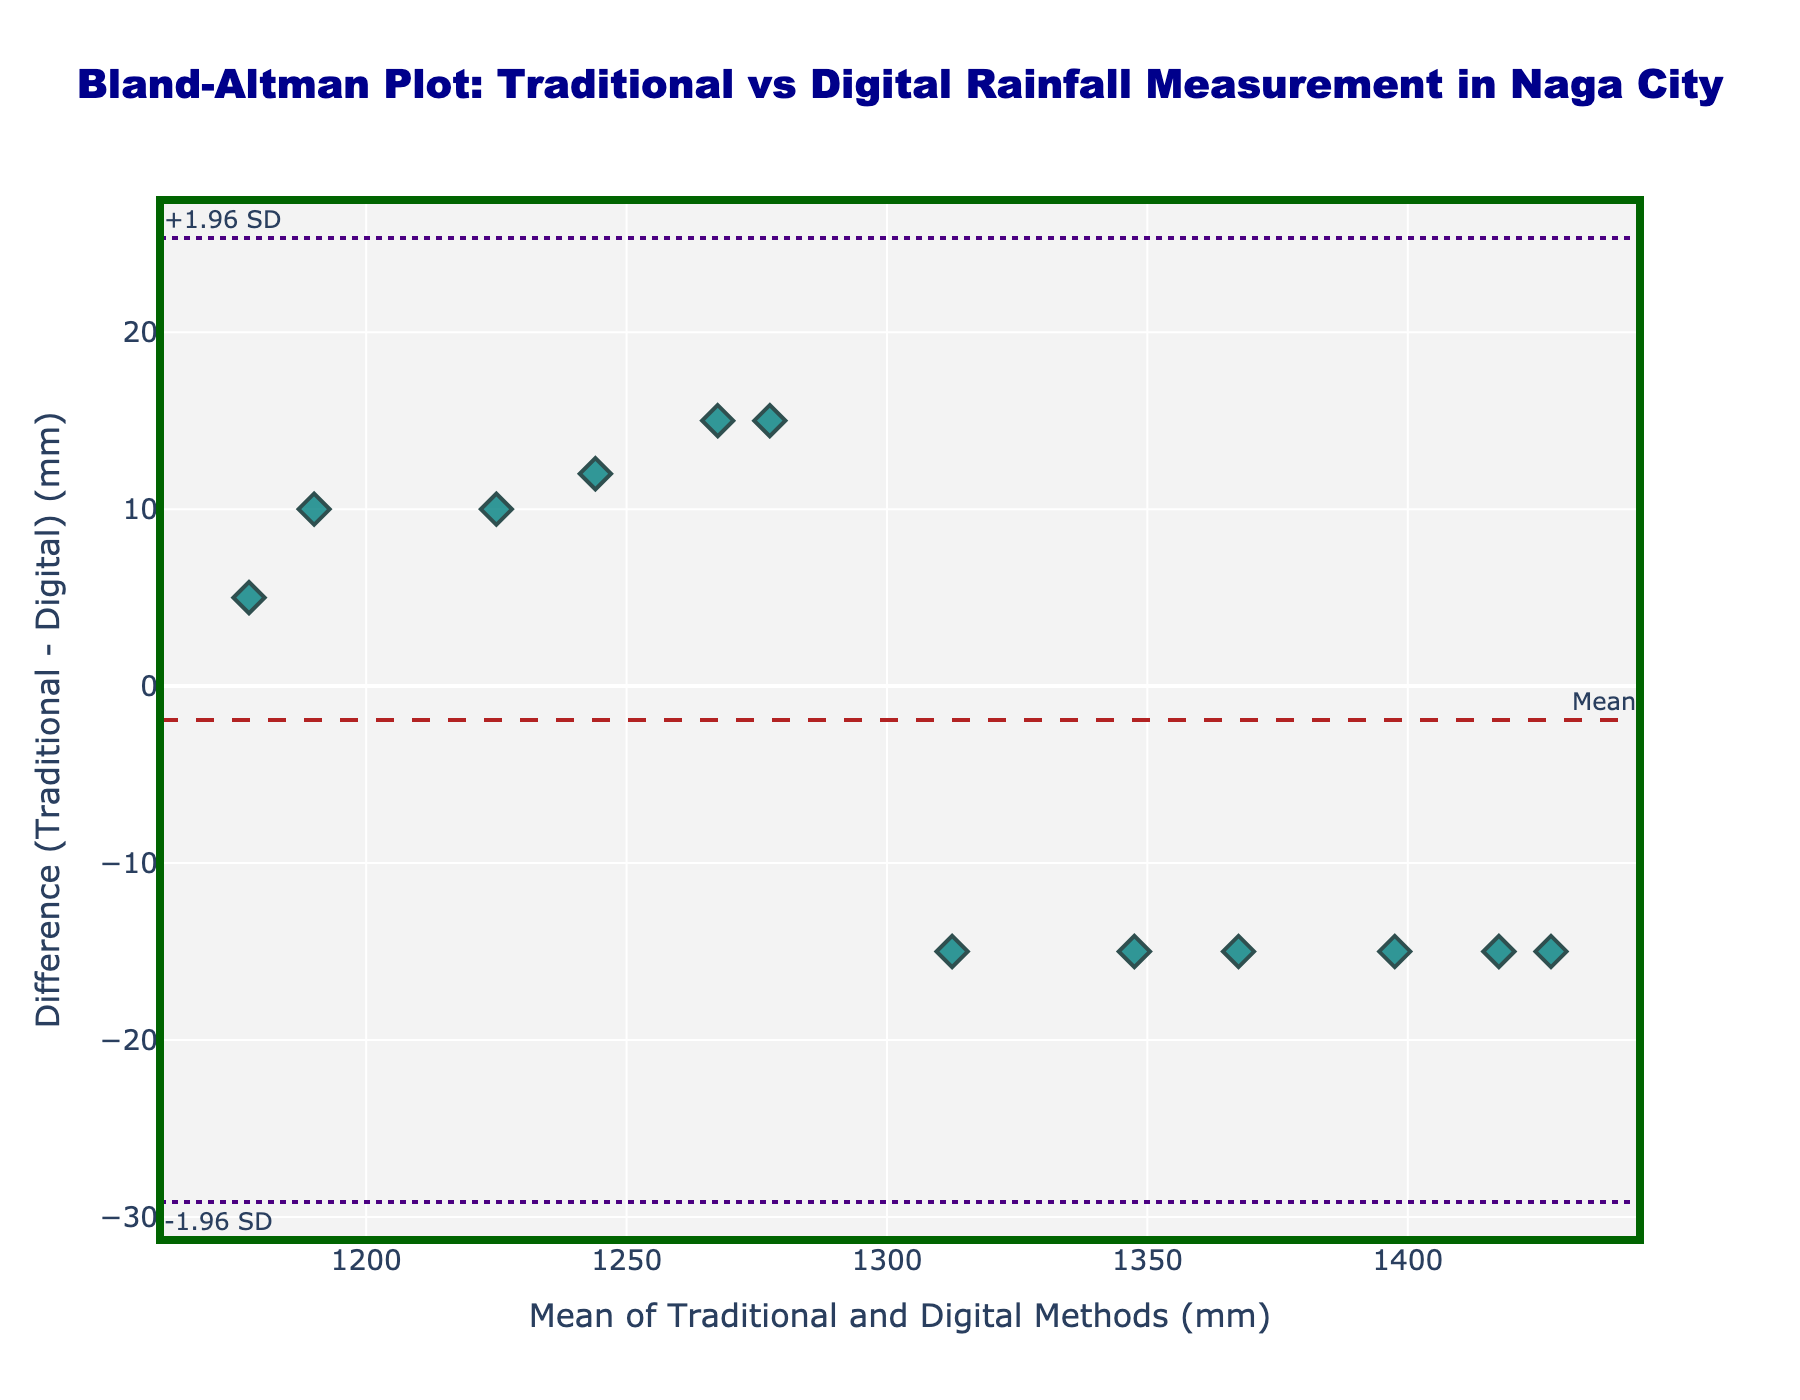What's the title of the figure? The title of the figure is located at the top-center and provides a brief description of the plot's purpose. Here, it reads "Bland-Altman Plot: Traditional vs Digital Rainfall Measurement in Naga City."
Answer: "Bland-Altman Plot: Traditional vs Digital Rainfall Measurement in Naga City" How many data points are plotted? Count the number of unique marker points displayed in the plot. Each represents a pair of traditional and digital measurements. By counting, there are 12 points.
Answer: 12 What is represented by the dashed line in the plot? The dashed line is annotated with "Mean" and typically represents the mean difference between the traditional and digital measurements. It's the average difference of all the points plotted.
Answer: Mean difference What do the dotted lines signify? The plot has two dotted horizontal lines annotated with "+1.96 SD" and "-1.96 SD," which indicate the upper and lower limits of agreement (LOA). They represent the mean difference plus and minus 1.96 times the standard deviation of the differences.
Answer: Limits of Agreement What is the difference between the traditional and digital measurements when the mean (average of traditional and digital) is 1312.5 mm? Locate the data point where the x-value (mean) is 1312.5 mm. Then, observe the corresponding y-value, which represents the difference between traditional and digital measurements. Here, the difference is -15 mm.
Answer: -15 mm How many data points fall outside the limits of agreement (LOA)? Count the number of data points that lie above the upper LOA or below the lower LOA. In this plot, none of the points lie outside these limits.
Answer: 0 What are the mean and the differences: traditional vs. digital measurements when the mean is 1202.5 mm? Find the data point where the mean is 1202.5 mm. The difference value is -5 mm, indicating traditional is slightly higher compared to digital.
Answer: -5 mm Based on the plot, can we determine which method consistently measures higher? Since the differences (traditional - digital) are scattered around the mean line and both positive and negative, neither method consistently measures higher. The distribution of differences suggests no consistent bias.
Answer: No consistent method What is the value of the upper limit of agreement (upper LOA)? The upper LOA is marked by the top dotted line and annotated with "+1.96 SD," representing the mean difference plus 1.96 times the standard deviation of differences. The actual value is around 16.6 mm.
Answer: 16.6 mm Are most of the differences within an acceptable range as indicated by the LOA? Examine whether the majority of plotted points fall between the upper and lower LOA lines. Since all points lie within these boundaries, it suggests that most differences are within an acceptable range.
Answer: Yes 